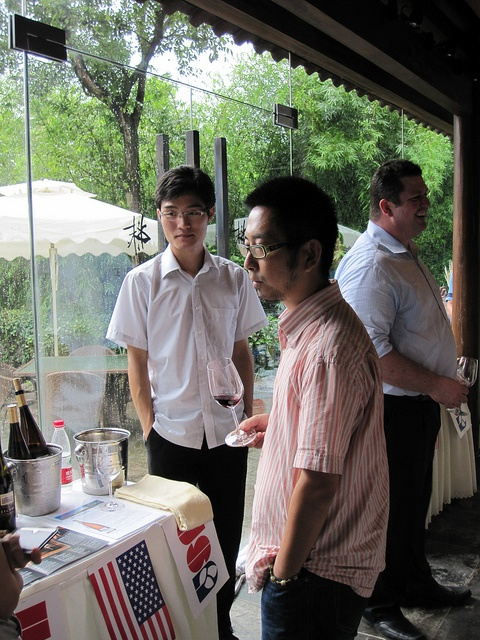Describe the objects in this image and their specific colors. I can see people in white, black, gray, maroon, and lightgray tones, people in white, darkgray, black, gray, and lightgray tones, people in white, black, gray, maroon, and darkgray tones, dining table in white, darkgray, gray, lavender, and maroon tones, and umbrella in white, darkgray, beige, and gray tones in this image. 